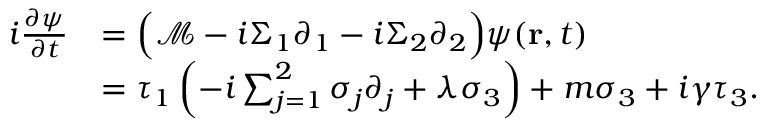Convert formula to latex. <formula><loc_0><loc_0><loc_500><loc_500>\begin{array} { r } { \begin{array} { r l } { i \frac { \partial \psi } { \partial t } } & { = \left ( \mathcal { M } - i \Sigma _ { 1 } \partial _ { 1 } - i \Sigma _ { 2 } \partial _ { 2 } \right ) \psi ( r , t ) } \\ & { = \tau _ { 1 } \left ( - i \sum _ { j = 1 } ^ { 2 } \sigma _ { j } \partial _ { j } + \lambda \sigma _ { 3 } \right ) + m \sigma _ { 3 } + i \gamma \tau _ { 3 } . } \end{array} } \end{array}</formula> 